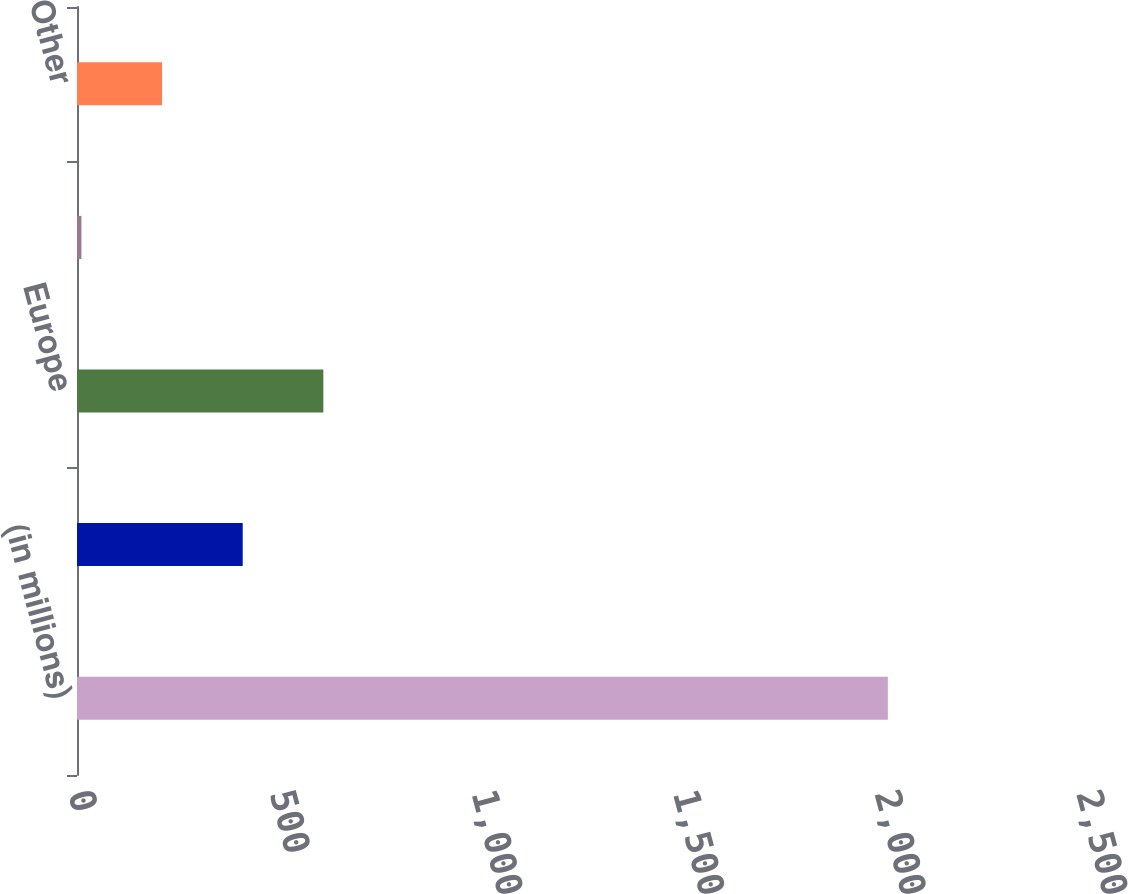<chart> <loc_0><loc_0><loc_500><loc_500><bar_chart><fcel>(in millions)<fcel>United States<fcel>Europe<fcel>Asia Pacific<fcel>Other<nl><fcel>2011<fcel>411<fcel>611<fcel>11<fcel>211<nl></chart> 